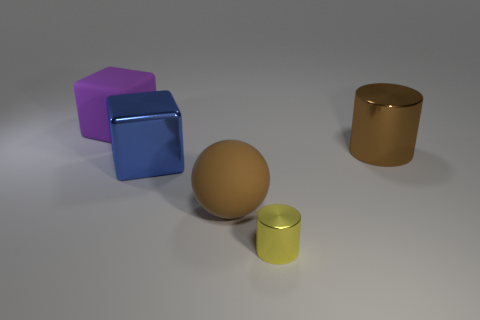What is the color of the other rubber object that is the same size as the brown rubber object?
Keep it short and to the point. Purple. There is a tiny cylinder; how many rubber objects are in front of it?
Offer a terse response. 0. Are any tiny blue matte objects visible?
Offer a terse response. No. How big is the brown object that is in front of the big metal thing on the left side of the cylinder behind the big matte sphere?
Offer a terse response. Large. What number of other objects are there of the same size as the ball?
Make the answer very short. 3. How big is the brown thing that is to the left of the large cylinder?
Ensure brevity in your answer.  Large. Is there any other thing that has the same color as the large matte cube?
Provide a short and direct response. No. Is the big thing to the right of the rubber ball made of the same material as the brown ball?
Offer a terse response. No. What number of large objects are both in front of the big rubber block and left of the big brown ball?
Give a very brief answer. 1. What is the size of the thing that is in front of the large rubber object on the right side of the purple block?
Your answer should be compact. Small. 